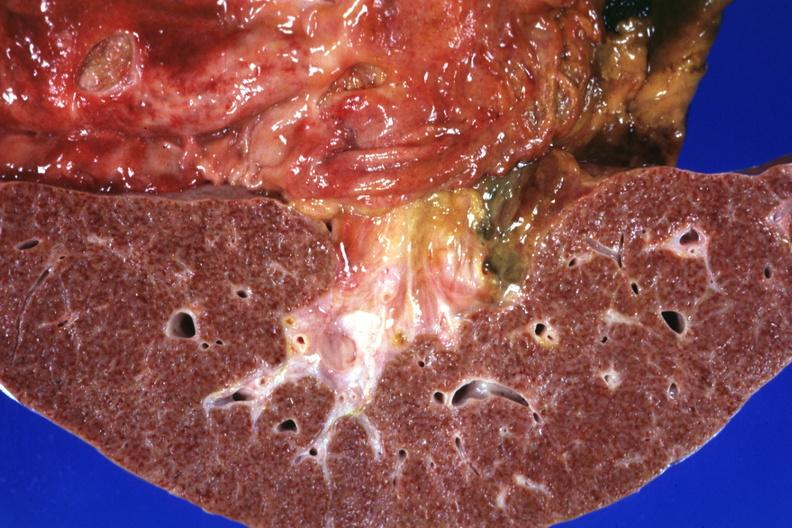what does this frontal section micronodular photo show?
Answer the question using a single word or phrase. Gastric and duodenal ulcers 